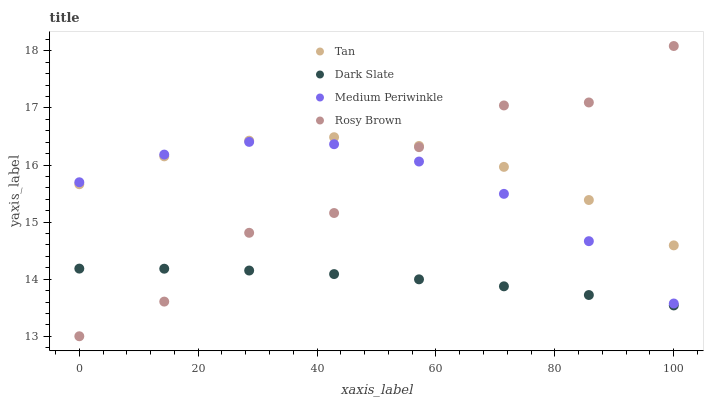Does Dark Slate have the minimum area under the curve?
Answer yes or no. Yes. Does Tan have the maximum area under the curve?
Answer yes or no. Yes. Does Rosy Brown have the minimum area under the curve?
Answer yes or no. No. Does Rosy Brown have the maximum area under the curve?
Answer yes or no. No. Is Dark Slate the smoothest?
Answer yes or no. Yes. Is Rosy Brown the roughest?
Answer yes or no. Yes. Is Tan the smoothest?
Answer yes or no. No. Is Tan the roughest?
Answer yes or no. No. Does Rosy Brown have the lowest value?
Answer yes or no. Yes. Does Tan have the lowest value?
Answer yes or no. No. Does Rosy Brown have the highest value?
Answer yes or no. Yes. Does Tan have the highest value?
Answer yes or no. No. Is Dark Slate less than Tan?
Answer yes or no. Yes. Is Medium Periwinkle greater than Dark Slate?
Answer yes or no. Yes. Does Medium Periwinkle intersect Rosy Brown?
Answer yes or no. Yes. Is Medium Periwinkle less than Rosy Brown?
Answer yes or no. No. Is Medium Periwinkle greater than Rosy Brown?
Answer yes or no. No. Does Dark Slate intersect Tan?
Answer yes or no. No. 